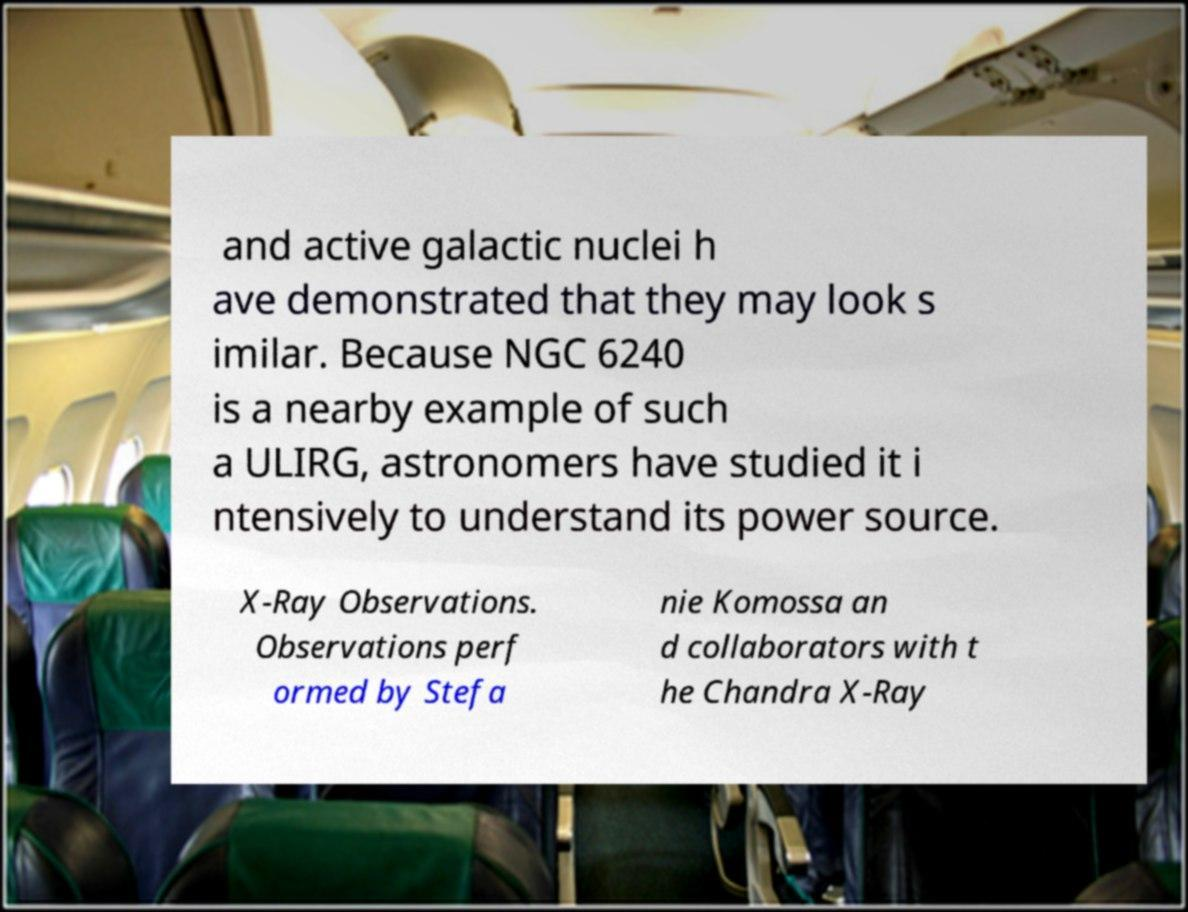Can you accurately transcribe the text from the provided image for me? and active galactic nuclei h ave demonstrated that they may look s imilar. Because NGC 6240 is a nearby example of such a ULIRG, astronomers have studied it i ntensively to understand its power source. X-Ray Observations. Observations perf ormed by Stefa nie Komossa an d collaborators with t he Chandra X-Ray 